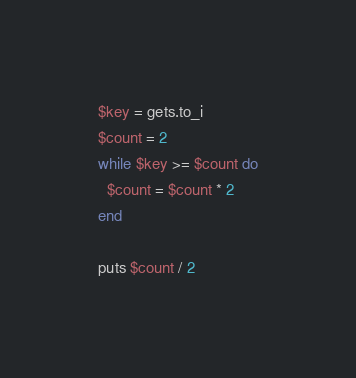<code> <loc_0><loc_0><loc_500><loc_500><_Ruby_>$key = gets.to_i
$count = 2
while $key >= $count do
  $count = $count * 2
end

puts $count / 2
</code> 